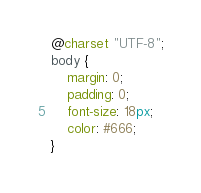Convert code to text. <code><loc_0><loc_0><loc_500><loc_500><_CSS_>@charset "UTF-8";
body {
    margin: 0;
    padding: 0;
    font-size: 18px;
    color: #666;
}</code> 